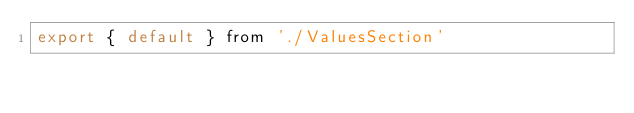<code> <loc_0><loc_0><loc_500><loc_500><_JavaScript_>export { default } from './ValuesSection'
</code> 